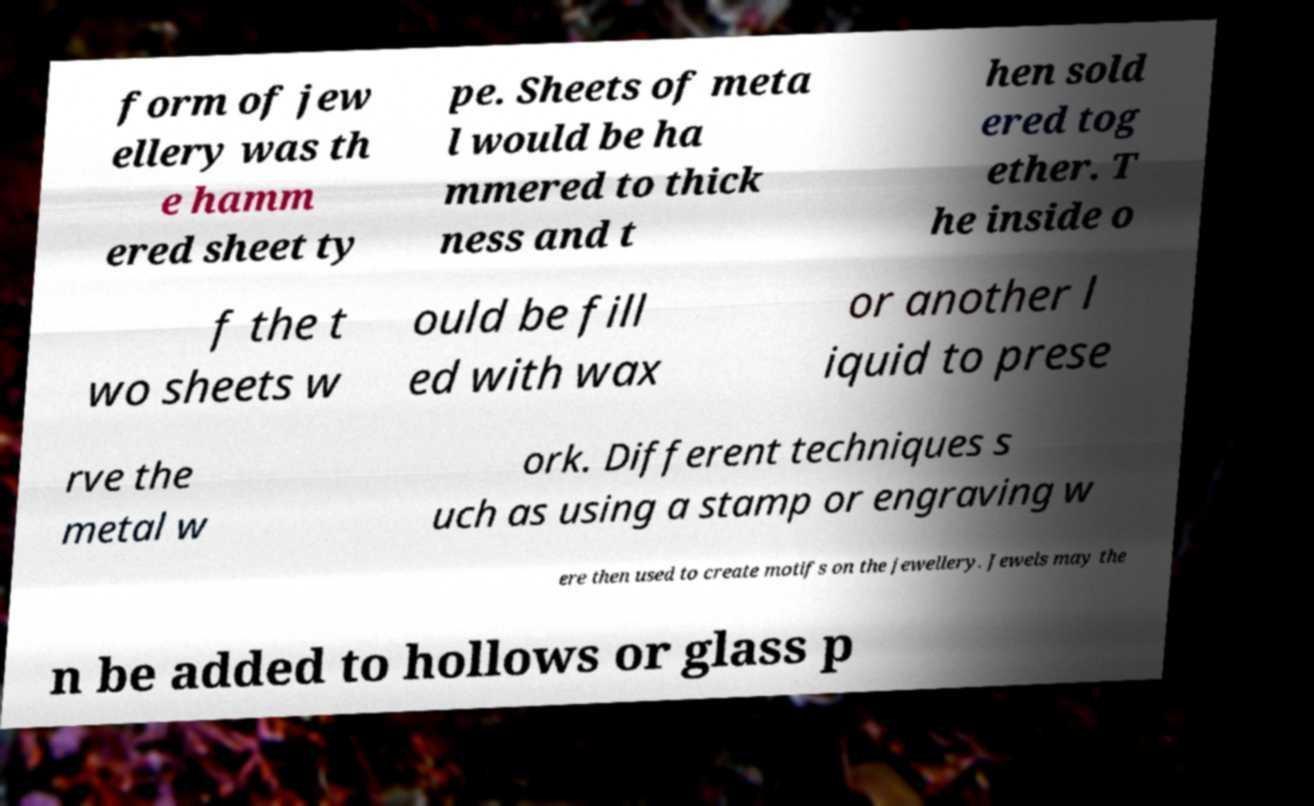What messages or text are displayed in this image? I need them in a readable, typed format. form of jew ellery was th e hamm ered sheet ty pe. Sheets of meta l would be ha mmered to thick ness and t hen sold ered tog ether. T he inside o f the t wo sheets w ould be fill ed with wax or another l iquid to prese rve the metal w ork. Different techniques s uch as using a stamp or engraving w ere then used to create motifs on the jewellery. Jewels may the n be added to hollows or glass p 